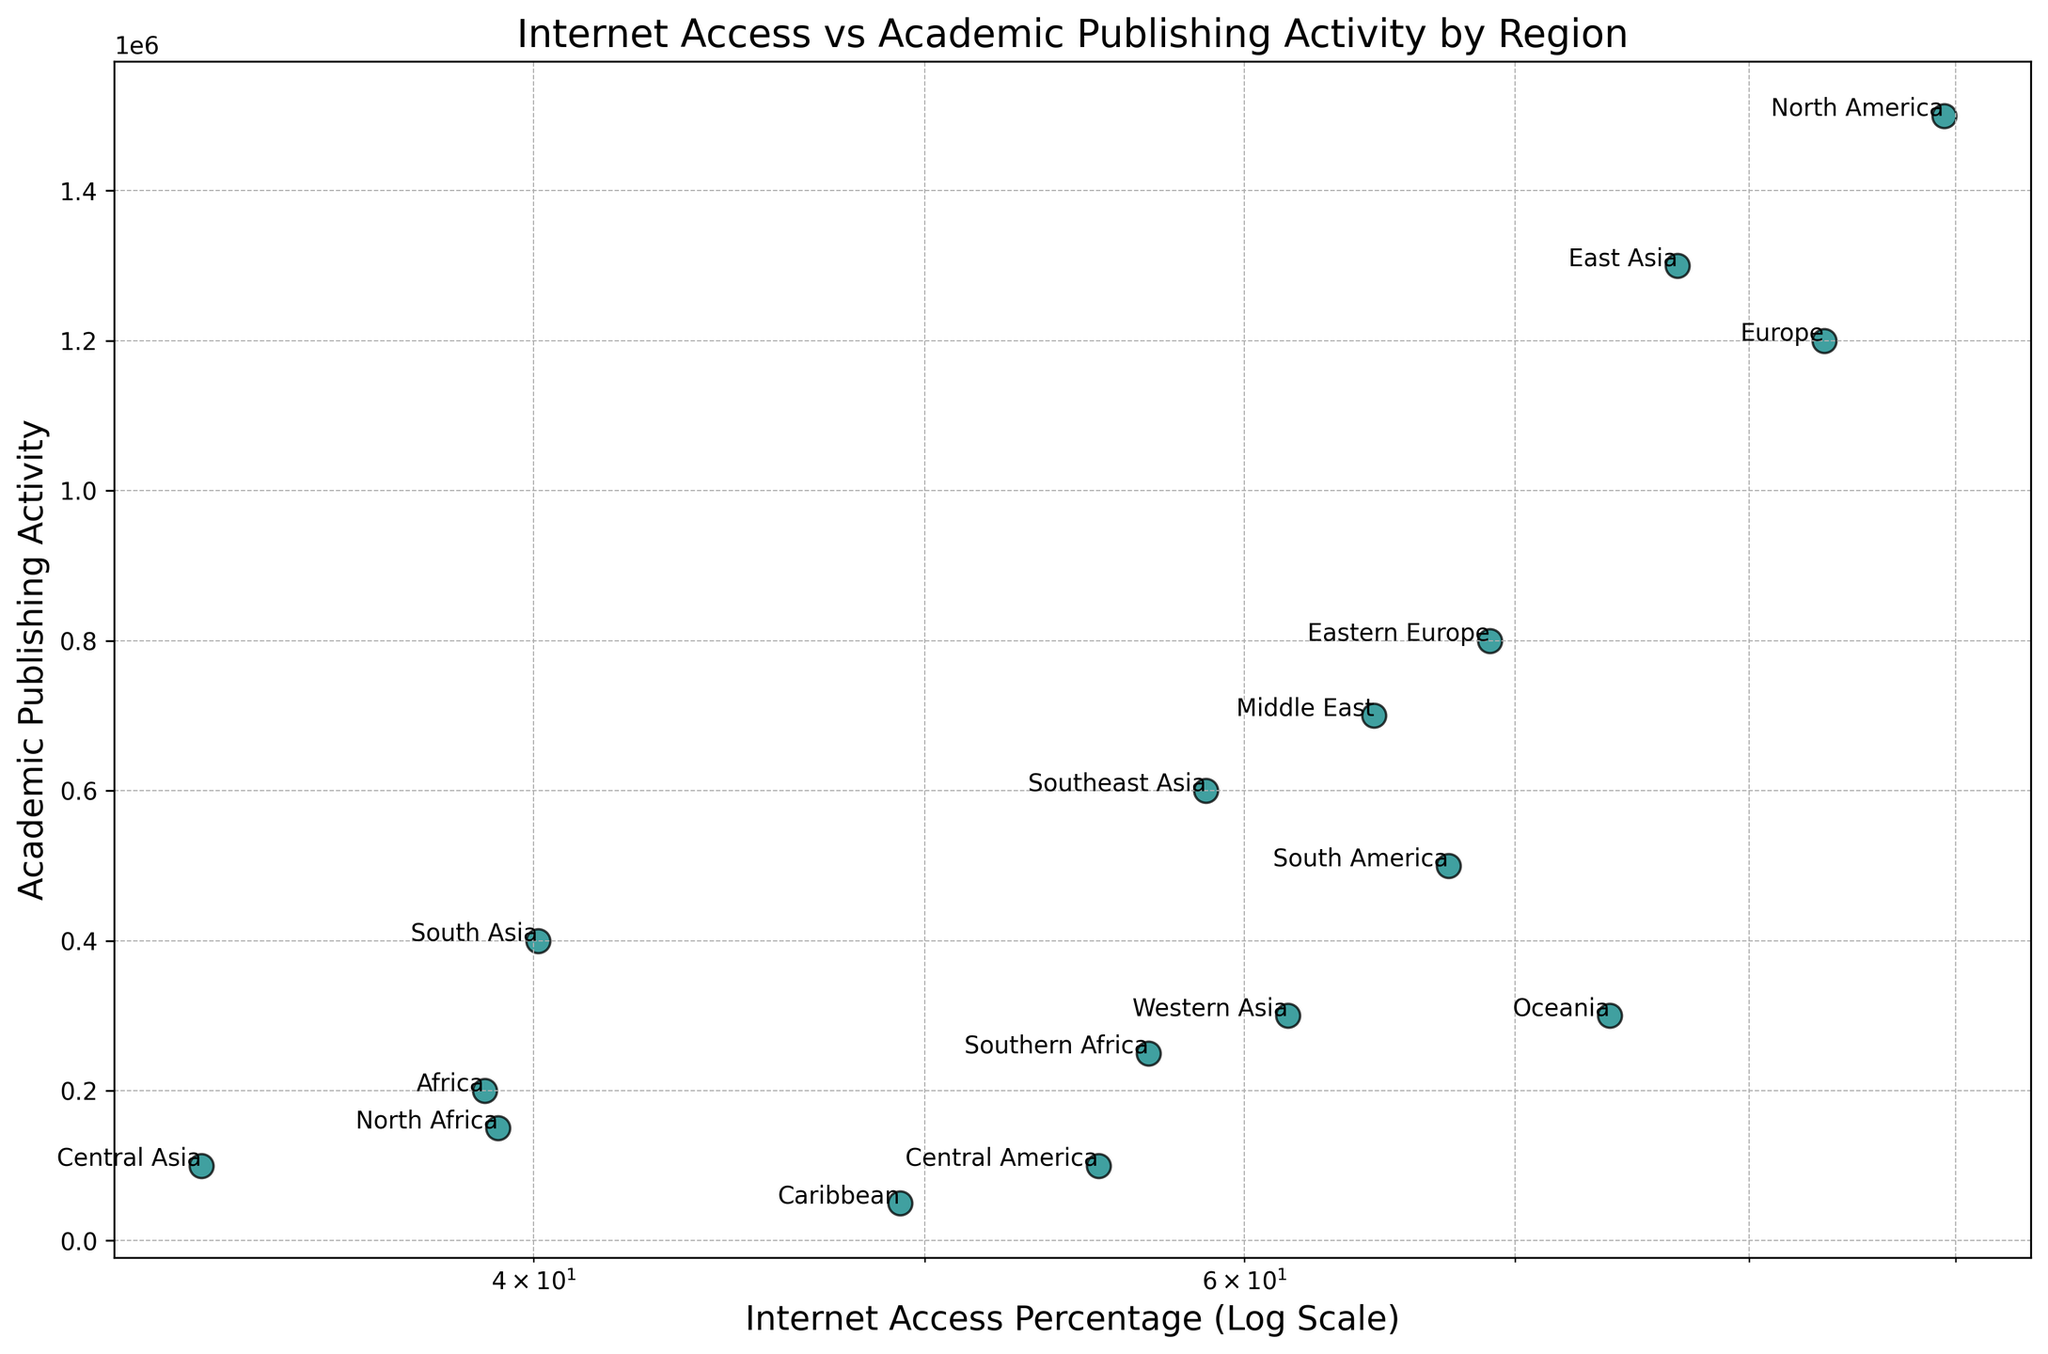What's the region with the highest internet access percentage? The figure shows the internet access percentages on a logarithmic scale. By examining the point farthest to the right on the x-axis, we see that North America has the highest internet access percentage.
Answer: North America Which region has the lowest academic publishing activity? The vertical position of the points indicates the academic publishing activity. The lowest point on the y-axis corresponds to the region with the lowest activity, which is the Caribbean.
Answer: Caribbean How does Europe compare to South America in terms of academic publishing activity? Europe and South America can be located by their labels. Comparing their vertical positions, Europe is higher than South America, indicating higher academic publishing activity in Europe.
Answer: Europe has higher academic publishing activity than South America What's the difference in internet access percentage between South Asia and Central Asia? Locate both regions on the x-axis. South Asia is at 40.1%, and Central Asia is at 33.1%. The difference is calculated as 40.1% - 33.1% = 7%.
Answer: 7% What's the average academic publishing activity of Eastern Europe, Middle East, and Southeast Asia? Find these regions on the y-axis: Eastern Europe at 800,000, Middle East at 700,000, and Southeast Asia at 600,000. Calculate the average as (800,000 + 700,000 + 600,000) / 3 = 700,000.
Answer: 700,000 Which regions have higher than 60% internet access but lower than 600,000 academic publishing activity? Identify regions above 60% on the x-axis and below 600,000 on the y-axis. These regions are Oceania (73.9%, 300,000) and Western Asia (61.5%, 300,000).
Answer: Oceania, Western Asia Find the region with the median internet access percentage. Arrange the internet access percentages in ascending order: 33.1, 38.9, 39.2, 40.1, 49.3, 55.2, 56.8, 58.7, 61.5, 64.6, 67.4, 69.0, 73.9, 76.8, 83.5, 89.4. The median value is the 8th and 9th values: (58.7 + 61.5) / 2 = 60.1%. Southeast Asia is closest to this value.
Answer: Southeast Asia Which region shows the largest gap between internet access percentage and academic publishing activity? To compare gaps, examine regions where the x and y values have the greatest difference for either high/low internet access to low/high publishing activity. North America has both extreme values (89.4% internet access, 1,500,000 publishing activity), suggesting the largest gap.
Answer: North America Is there a region with more than 70% internet access but fewer than 400,000 academic publications? Look at points to the right of the 70% (logarithmic) mark on the x-axis and below the 400,000 mark on the y-axis. Oceania (73.9%, 300,000) fits this criterion.
Answer: Oceania 